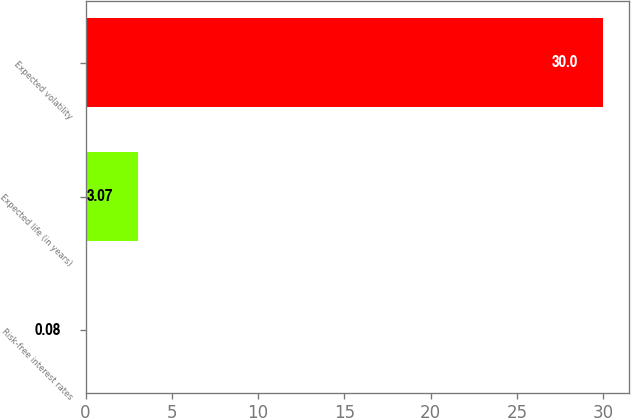Convert chart to OTSL. <chart><loc_0><loc_0><loc_500><loc_500><bar_chart><fcel>Risk-free interest rates<fcel>Expected life (in years)<fcel>Expected volatility<nl><fcel>0.08<fcel>3.07<fcel>30<nl></chart> 